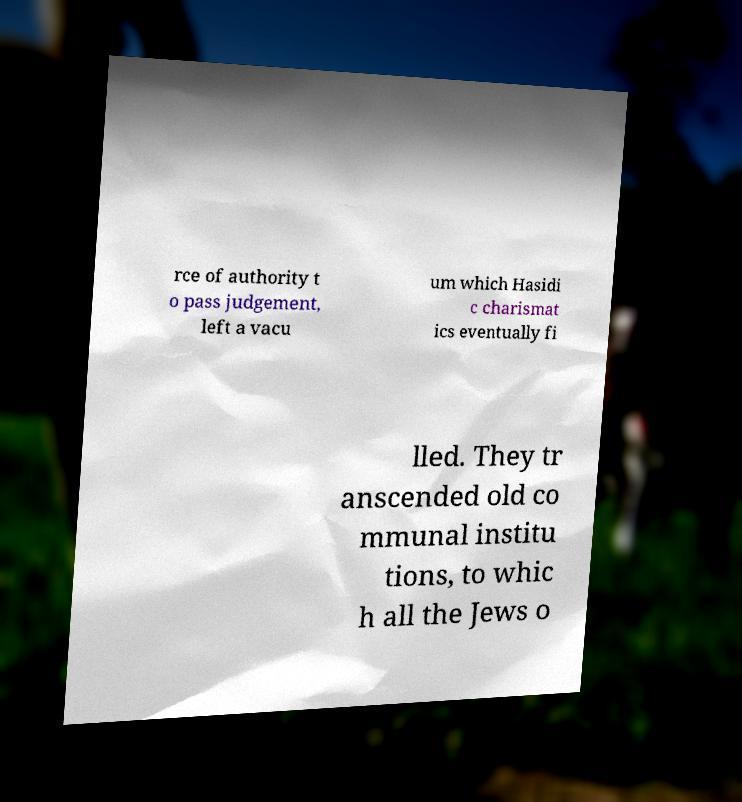What messages or text are displayed in this image? I need them in a readable, typed format. rce of authority t o pass judgement, left a vacu um which Hasidi c charismat ics eventually fi lled. They tr anscended old co mmunal institu tions, to whic h all the Jews o 